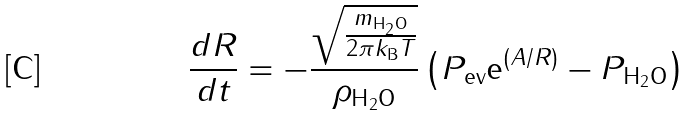Convert formula to latex. <formula><loc_0><loc_0><loc_500><loc_500>\frac { d R } { d t } = - \frac { \sqrt { \frac { m _ { \text {H} _ { 2 } \text {O} } } { 2 \pi k _ { \text {B} } T } } } { \rho _ { \text {H} _ { 2 } \text {O} } } \left ( P _ { \text {ev} } \text {e} ^ { \left ( A / R \right ) } - P _ { \text {H} _ { 2 } \text {O} } \right )</formula> 